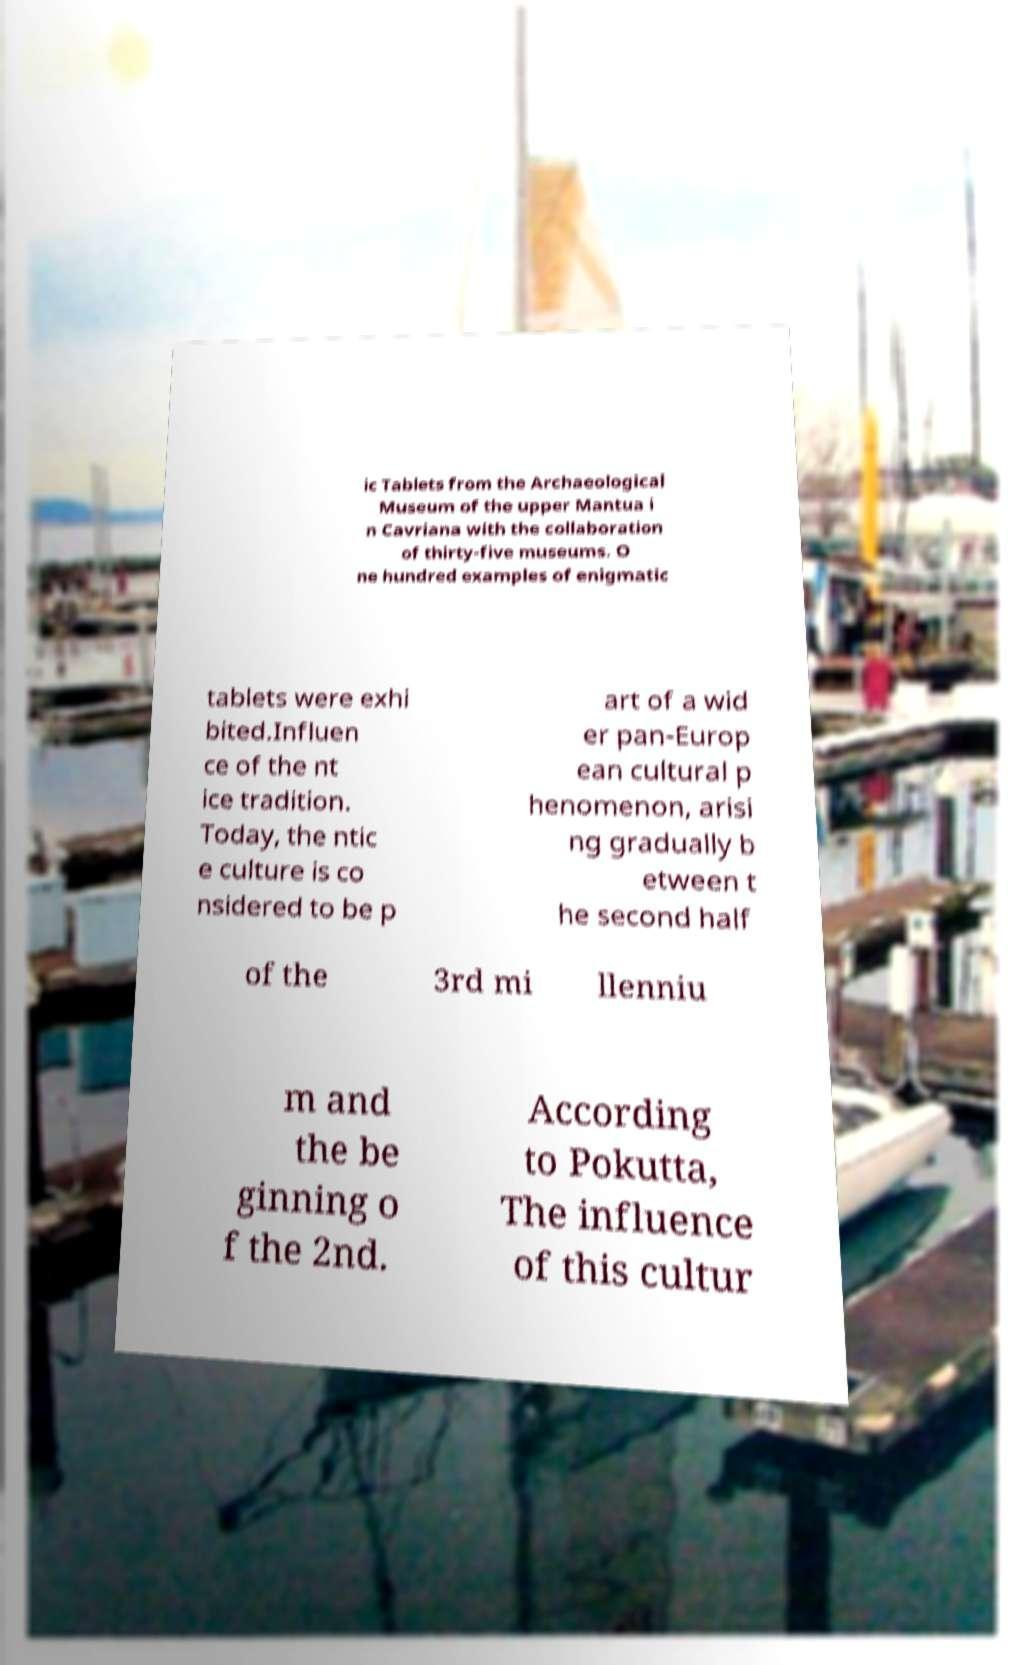Please identify and transcribe the text found in this image. ic Tablets from the Archaeological Museum of the upper Mantua i n Cavriana with the collaboration of thirty-five museums. O ne hundred examples of enigmatic tablets were exhi bited.Influen ce of the nt ice tradition. Today, the ntic e culture is co nsidered to be p art of a wid er pan-Europ ean cultural p henomenon, arisi ng gradually b etween t he second half of the 3rd mi llenniu m and the be ginning o f the 2nd. According to Pokutta, The influence of this cultur 